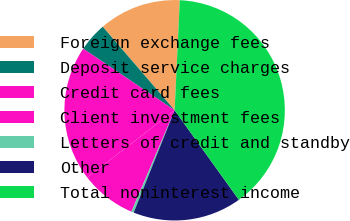Convert chart. <chart><loc_0><loc_0><loc_500><loc_500><pie_chart><fcel>Foreign exchange fees<fcel>Deposit service charges<fcel>Credit card fees<fcel>Client investment fees<fcel>Letters of credit and standby<fcel>Other<fcel>Total noninterest income<nl><fcel>12.06%<fcel>4.26%<fcel>19.86%<fcel>8.16%<fcel>0.36%<fcel>15.96%<fcel>39.35%<nl></chart> 